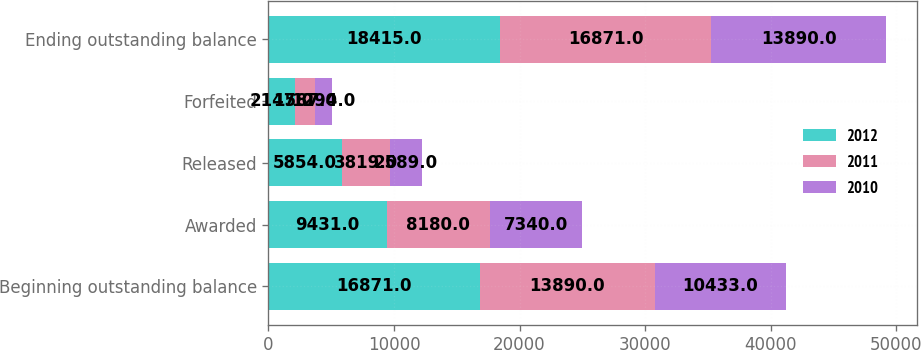<chart> <loc_0><loc_0><loc_500><loc_500><stacked_bar_chart><ecel><fcel>Beginning outstanding balance<fcel>Awarded<fcel>Released<fcel>Forfeited<fcel>Ending outstanding balance<nl><fcel>2012<fcel>16871<fcel>9431<fcel>5854<fcel>2147<fcel>18415<nl><fcel>2011<fcel>13890<fcel>8180<fcel>3819<fcel>1587<fcel>16871<nl><fcel>2010<fcel>10433<fcel>7340<fcel>2589<fcel>1294<fcel>13890<nl></chart> 